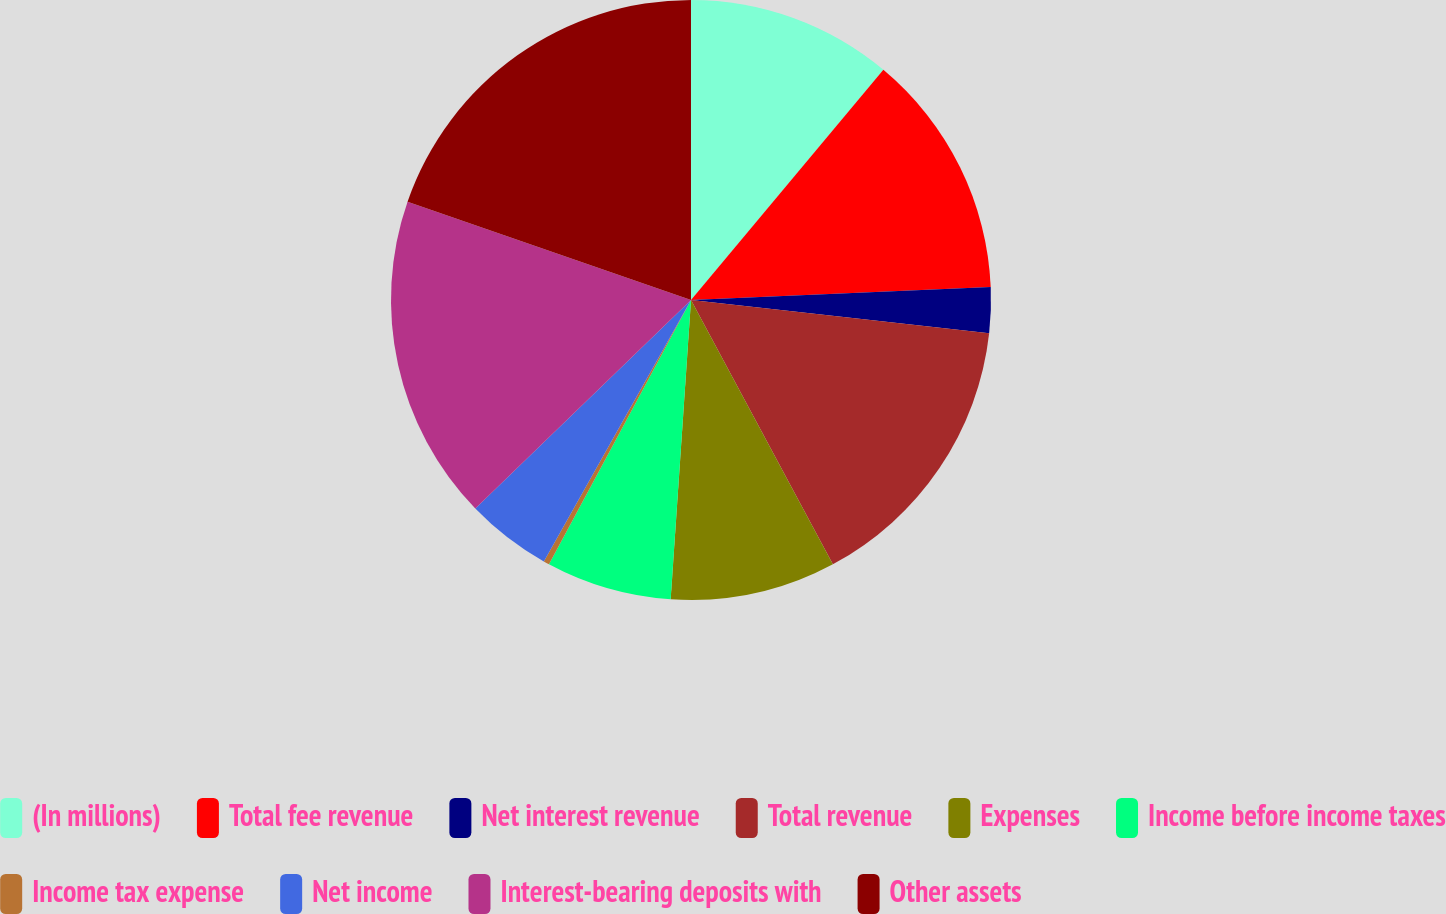Convert chart. <chart><loc_0><loc_0><loc_500><loc_500><pie_chart><fcel>(In millions)<fcel>Total fee revenue<fcel>Net interest revenue<fcel>Total revenue<fcel>Expenses<fcel>Income before income taxes<fcel>Income tax expense<fcel>Net income<fcel>Interest-bearing deposits with<fcel>Other assets<nl><fcel>11.08%<fcel>13.23%<fcel>2.46%<fcel>15.39%<fcel>8.92%<fcel>6.77%<fcel>0.31%<fcel>4.61%<fcel>17.54%<fcel>19.69%<nl></chart> 